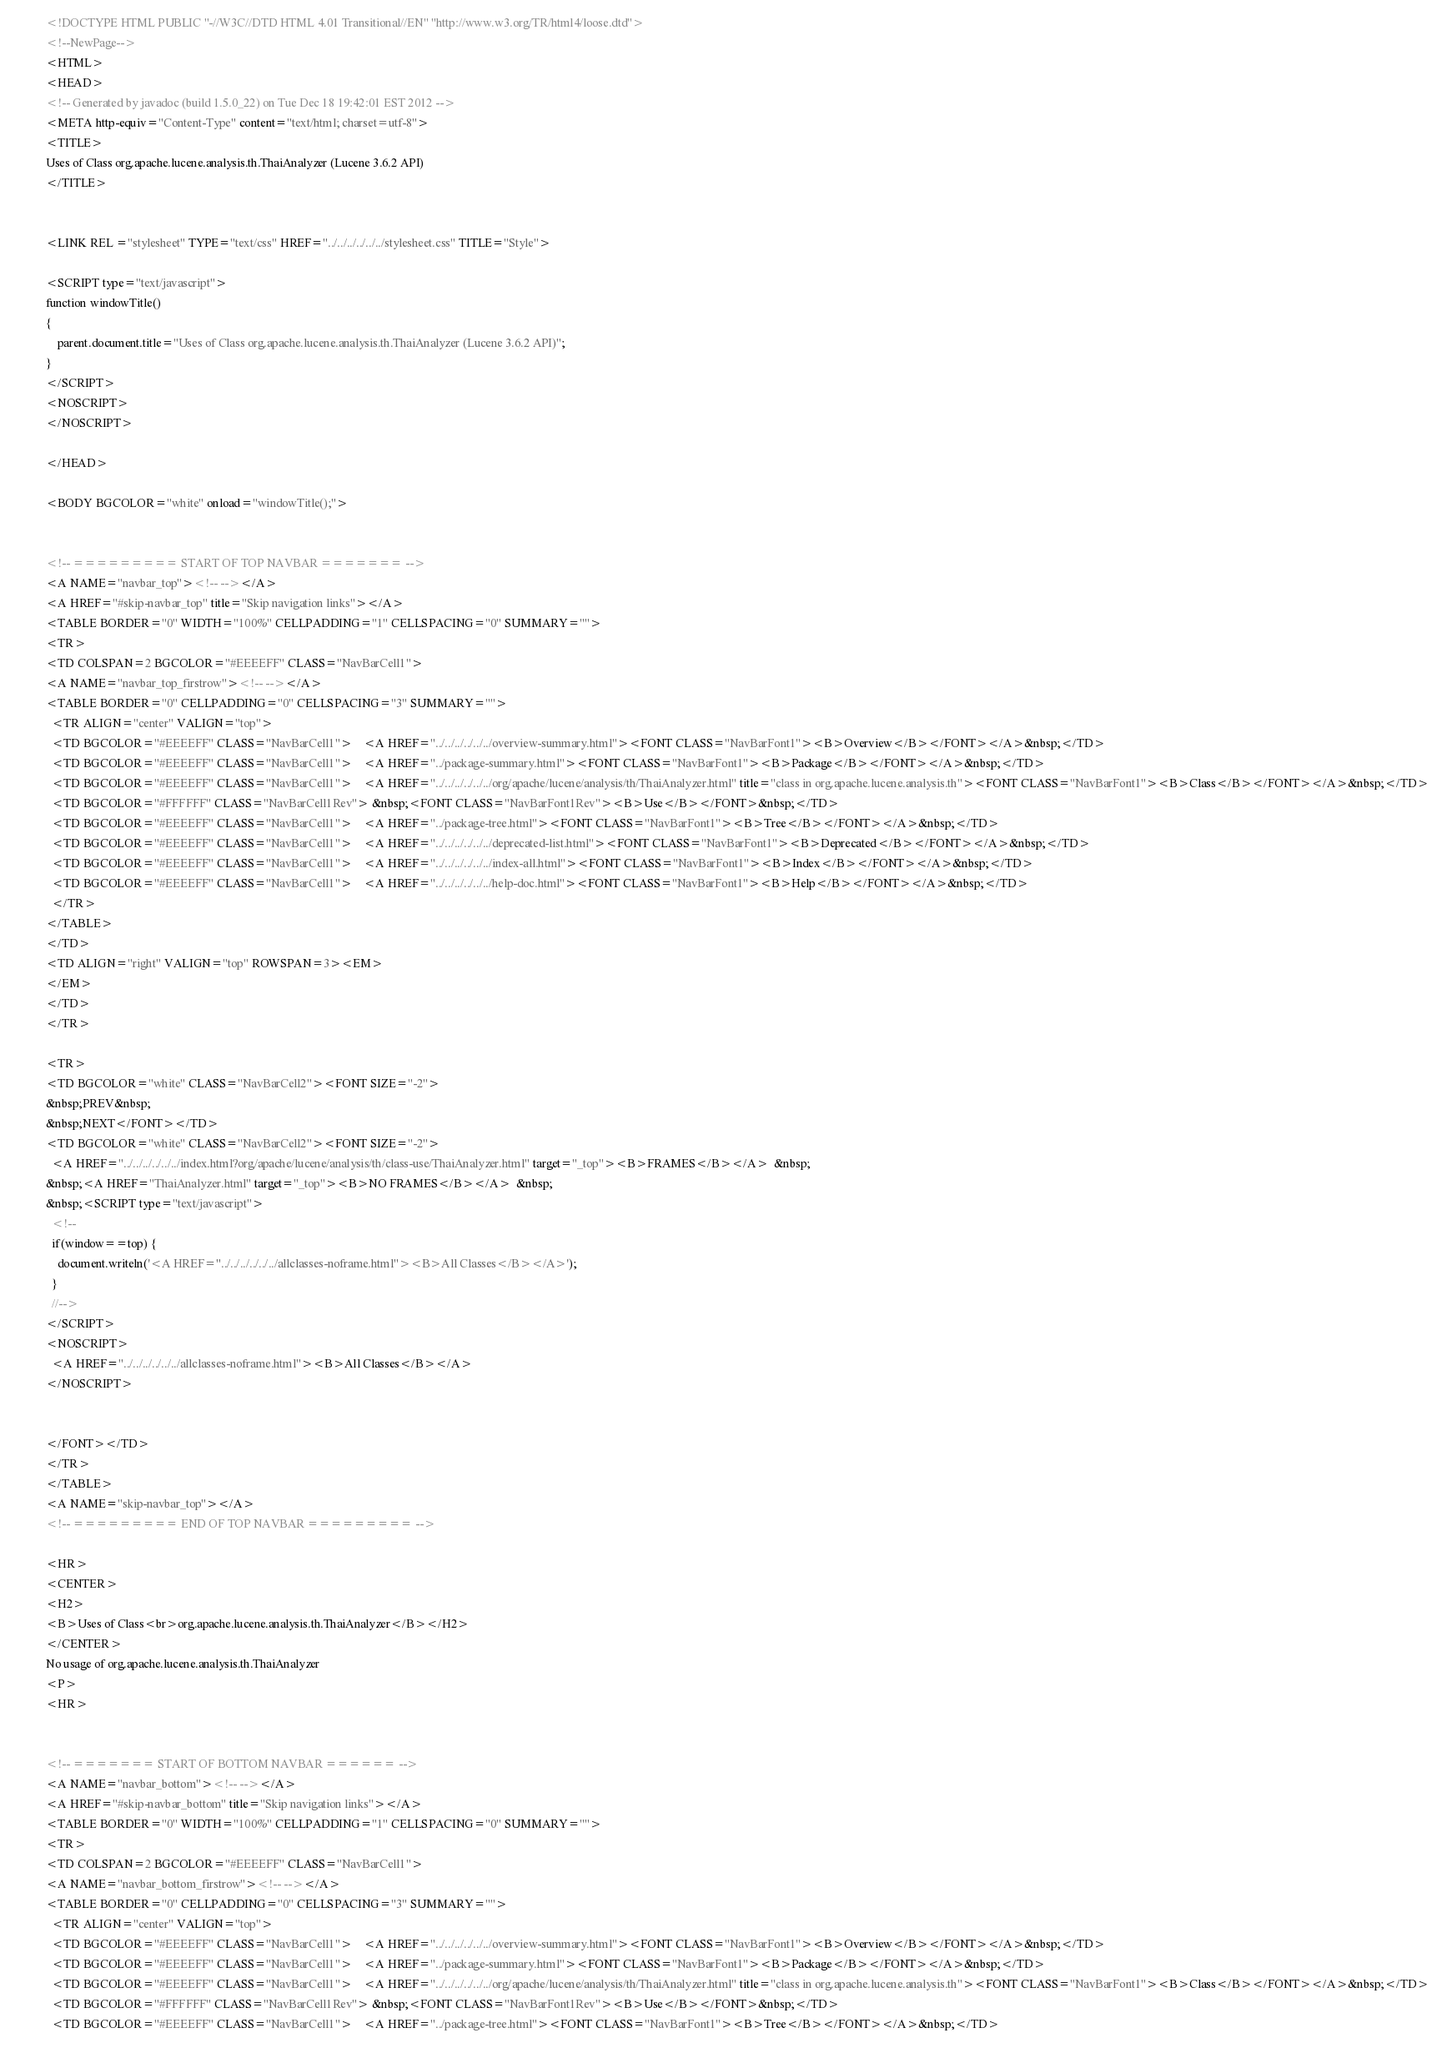<code> <loc_0><loc_0><loc_500><loc_500><_HTML_><!DOCTYPE HTML PUBLIC "-//W3C//DTD HTML 4.01 Transitional//EN" "http://www.w3.org/TR/html4/loose.dtd">
<!--NewPage-->
<HTML>
<HEAD>
<!-- Generated by javadoc (build 1.5.0_22) on Tue Dec 18 19:42:01 EST 2012 -->
<META http-equiv="Content-Type" content="text/html; charset=utf-8">
<TITLE>
Uses of Class org.apache.lucene.analysis.th.ThaiAnalyzer (Lucene 3.6.2 API)
</TITLE>


<LINK REL ="stylesheet" TYPE="text/css" HREF="../../../../../../stylesheet.css" TITLE="Style">

<SCRIPT type="text/javascript">
function windowTitle()
{
    parent.document.title="Uses of Class org.apache.lucene.analysis.th.ThaiAnalyzer (Lucene 3.6.2 API)";
}
</SCRIPT>
<NOSCRIPT>
</NOSCRIPT>

</HEAD>

<BODY BGCOLOR="white" onload="windowTitle();">


<!-- ========= START OF TOP NAVBAR ======= -->
<A NAME="navbar_top"><!-- --></A>
<A HREF="#skip-navbar_top" title="Skip navigation links"></A>
<TABLE BORDER="0" WIDTH="100%" CELLPADDING="1" CELLSPACING="0" SUMMARY="">
<TR>
<TD COLSPAN=2 BGCOLOR="#EEEEFF" CLASS="NavBarCell1">
<A NAME="navbar_top_firstrow"><!-- --></A>
<TABLE BORDER="0" CELLPADDING="0" CELLSPACING="3" SUMMARY="">
  <TR ALIGN="center" VALIGN="top">
  <TD BGCOLOR="#EEEEFF" CLASS="NavBarCell1">    <A HREF="../../../../../../overview-summary.html"><FONT CLASS="NavBarFont1"><B>Overview</B></FONT></A>&nbsp;</TD>
  <TD BGCOLOR="#EEEEFF" CLASS="NavBarCell1">    <A HREF="../package-summary.html"><FONT CLASS="NavBarFont1"><B>Package</B></FONT></A>&nbsp;</TD>
  <TD BGCOLOR="#EEEEFF" CLASS="NavBarCell1">    <A HREF="../../../../../../org/apache/lucene/analysis/th/ThaiAnalyzer.html" title="class in org.apache.lucene.analysis.th"><FONT CLASS="NavBarFont1"><B>Class</B></FONT></A>&nbsp;</TD>
  <TD BGCOLOR="#FFFFFF" CLASS="NavBarCell1Rev"> &nbsp;<FONT CLASS="NavBarFont1Rev"><B>Use</B></FONT>&nbsp;</TD>
  <TD BGCOLOR="#EEEEFF" CLASS="NavBarCell1">    <A HREF="../package-tree.html"><FONT CLASS="NavBarFont1"><B>Tree</B></FONT></A>&nbsp;</TD>
  <TD BGCOLOR="#EEEEFF" CLASS="NavBarCell1">    <A HREF="../../../../../../deprecated-list.html"><FONT CLASS="NavBarFont1"><B>Deprecated</B></FONT></A>&nbsp;</TD>
  <TD BGCOLOR="#EEEEFF" CLASS="NavBarCell1">    <A HREF="../../../../../../index-all.html"><FONT CLASS="NavBarFont1"><B>Index</B></FONT></A>&nbsp;</TD>
  <TD BGCOLOR="#EEEEFF" CLASS="NavBarCell1">    <A HREF="../../../../../../help-doc.html"><FONT CLASS="NavBarFont1"><B>Help</B></FONT></A>&nbsp;</TD>
  </TR>
</TABLE>
</TD>
<TD ALIGN="right" VALIGN="top" ROWSPAN=3><EM>
</EM>
</TD>
</TR>

<TR>
<TD BGCOLOR="white" CLASS="NavBarCell2"><FONT SIZE="-2">
&nbsp;PREV&nbsp;
&nbsp;NEXT</FONT></TD>
<TD BGCOLOR="white" CLASS="NavBarCell2"><FONT SIZE="-2">
  <A HREF="../../../../../../index.html?org/apache/lucene/analysis/th/class-use/ThaiAnalyzer.html" target="_top"><B>FRAMES</B></A>  &nbsp;
&nbsp;<A HREF="ThaiAnalyzer.html" target="_top"><B>NO FRAMES</B></A>  &nbsp;
&nbsp;<SCRIPT type="text/javascript">
  <!--
  if(window==top) {
    document.writeln('<A HREF="../../../../../../allclasses-noframe.html"><B>All Classes</B></A>');
  }
  //-->
</SCRIPT>
<NOSCRIPT>
  <A HREF="../../../../../../allclasses-noframe.html"><B>All Classes</B></A>
</NOSCRIPT>


</FONT></TD>
</TR>
</TABLE>
<A NAME="skip-navbar_top"></A>
<!-- ========= END OF TOP NAVBAR ========= -->

<HR>
<CENTER>
<H2>
<B>Uses of Class<br>org.apache.lucene.analysis.th.ThaiAnalyzer</B></H2>
</CENTER>
No usage of org.apache.lucene.analysis.th.ThaiAnalyzer
<P>
<HR>


<!-- ======= START OF BOTTOM NAVBAR ====== -->
<A NAME="navbar_bottom"><!-- --></A>
<A HREF="#skip-navbar_bottom" title="Skip navigation links"></A>
<TABLE BORDER="0" WIDTH="100%" CELLPADDING="1" CELLSPACING="0" SUMMARY="">
<TR>
<TD COLSPAN=2 BGCOLOR="#EEEEFF" CLASS="NavBarCell1">
<A NAME="navbar_bottom_firstrow"><!-- --></A>
<TABLE BORDER="0" CELLPADDING="0" CELLSPACING="3" SUMMARY="">
  <TR ALIGN="center" VALIGN="top">
  <TD BGCOLOR="#EEEEFF" CLASS="NavBarCell1">    <A HREF="../../../../../../overview-summary.html"><FONT CLASS="NavBarFont1"><B>Overview</B></FONT></A>&nbsp;</TD>
  <TD BGCOLOR="#EEEEFF" CLASS="NavBarCell1">    <A HREF="../package-summary.html"><FONT CLASS="NavBarFont1"><B>Package</B></FONT></A>&nbsp;</TD>
  <TD BGCOLOR="#EEEEFF" CLASS="NavBarCell1">    <A HREF="../../../../../../org/apache/lucene/analysis/th/ThaiAnalyzer.html" title="class in org.apache.lucene.analysis.th"><FONT CLASS="NavBarFont1"><B>Class</B></FONT></A>&nbsp;</TD>
  <TD BGCOLOR="#FFFFFF" CLASS="NavBarCell1Rev"> &nbsp;<FONT CLASS="NavBarFont1Rev"><B>Use</B></FONT>&nbsp;</TD>
  <TD BGCOLOR="#EEEEFF" CLASS="NavBarCell1">    <A HREF="../package-tree.html"><FONT CLASS="NavBarFont1"><B>Tree</B></FONT></A>&nbsp;</TD></code> 